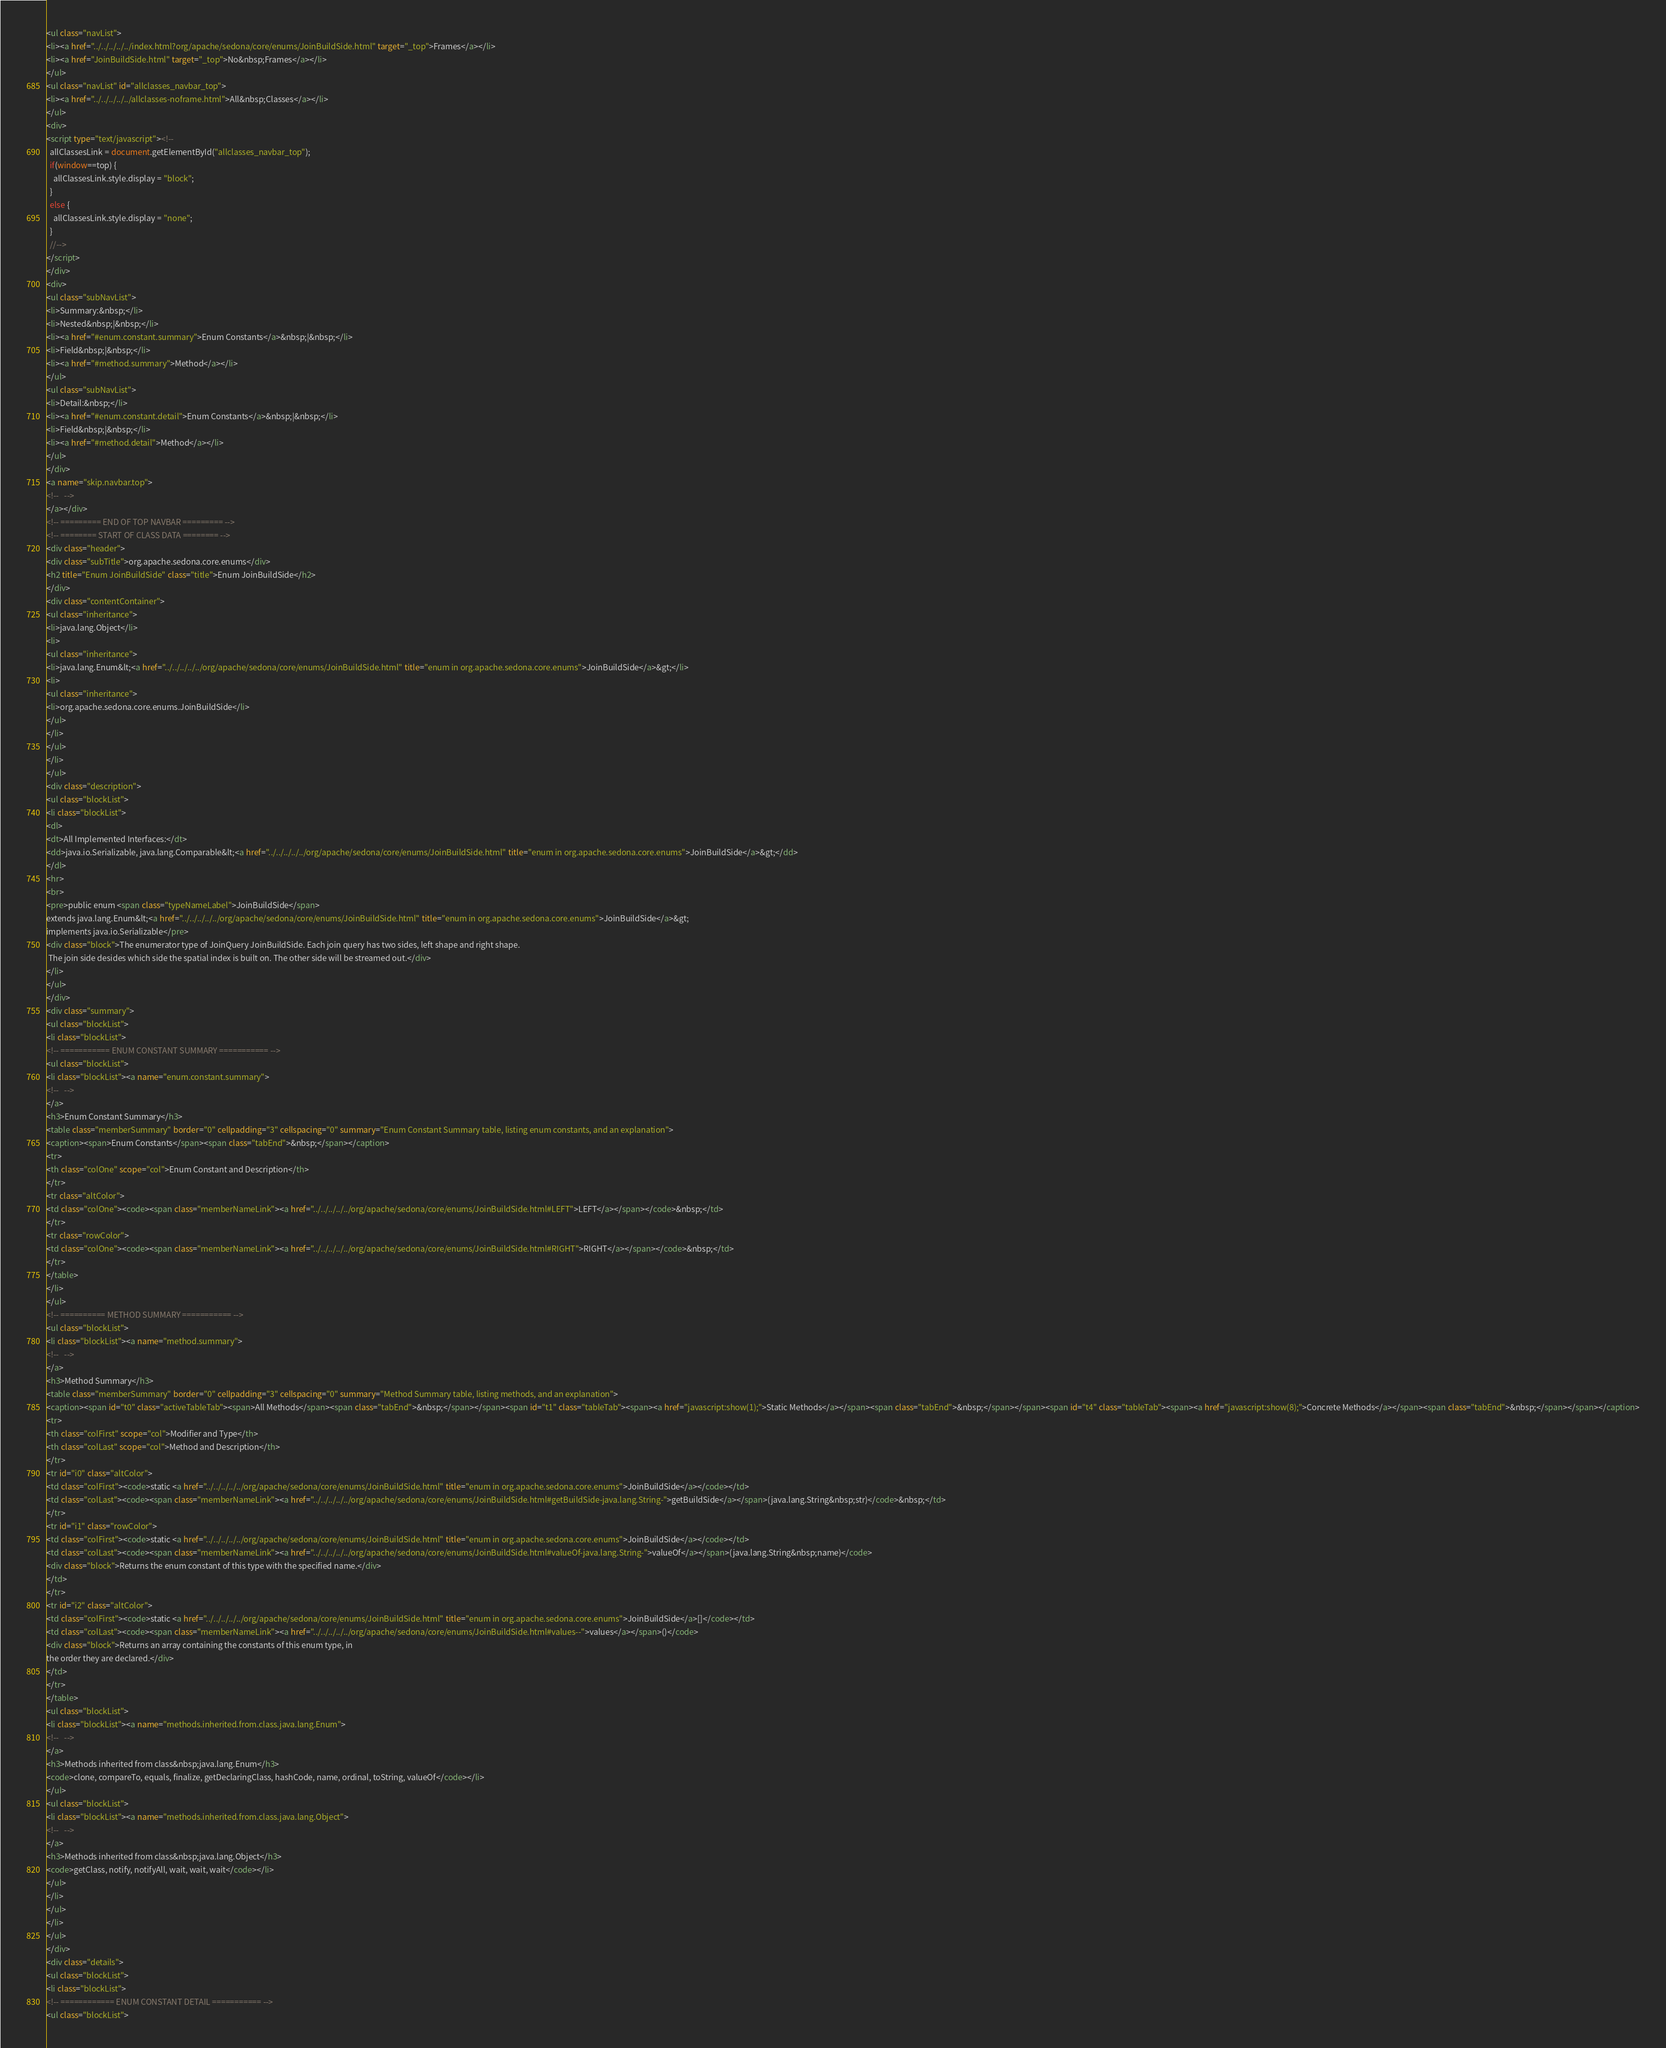Convert code to text. <code><loc_0><loc_0><loc_500><loc_500><_HTML_><ul class="navList">
<li><a href="../../../../../index.html?org/apache/sedona/core/enums/JoinBuildSide.html" target="_top">Frames</a></li>
<li><a href="JoinBuildSide.html" target="_top">No&nbsp;Frames</a></li>
</ul>
<ul class="navList" id="allclasses_navbar_top">
<li><a href="../../../../../allclasses-noframe.html">All&nbsp;Classes</a></li>
</ul>
<div>
<script type="text/javascript"><!--
  allClassesLink = document.getElementById("allclasses_navbar_top");
  if(window==top) {
    allClassesLink.style.display = "block";
  }
  else {
    allClassesLink.style.display = "none";
  }
  //-->
</script>
</div>
<div>
<ul class="subNavList">
<li>Summary:&nbsp;</li>
<li>Nested&nbsp;|&nbsp;</li>
<li><a href="#enum.constant.summary">Enum Constants</a>&nbsp;|&nbsp;</li>
<li>Field&nbsp;|&nbsp;</li>
<li><a href="#method.summary">Method</a></li>
</ul>
<ul class="subNavList">
<li>Detail:&nbsp;</li>
<li><a href="#enum.constant.detail">Enum Constants</a>&nbsp;|&nbsp;</li>
<li>Field&nbsp;|&nbsp;</li>
<li><a href="#method.detail">Method</a></li>
</ul>
</div>
<a name="skip.navbar.top">
<!--   -->
</a></div>
<!-- ========= END OF TOP NAVBAR ========= -->
<!-- ======== START OF CLASS DATA ======== -->
<div class="header">
<div class="subTitle">org.apache.sedona.core.enums</div>
<h2 title="Enum JoinBuildSide" class="title">Enum JoinBuildSide</h2>
</div>
<div class="contentContainer">
<ul class="inheritance">
<li>java.lang.Object</li>
<li>
<ul class="inheritance">
<li>java.lang.Enum&lt;<a href="../../../../../org/apache/sedona/core/enums/JoinBuildSide.html" title="enum in org.apache.sedona.core.enums">JoinBuildSide</a>&gt;</li>
<li>
<ul class="inheritance">
<li>org.apache.sedona.core.enums.JoinBuildSide</li>
</ul>
</li>
</ul>
</li>
</ul>
<div class="description">
<ul class="blockList">
<li class="blockList">
<dl>
<dt>All Implemented Interfaces:</dt>
<dd>java.io.Serializable, java.lang.Comparable&lt;<a href="../../../../../org/apache/sedona/core/enums/JoinBuildSide.html" title="enum in org.apache.sedona.core.enums">JoinBuildSide</a>&gt;</dd>
</dl>
<hr>
<br>
<pre>public enum <span class="typeNameLabel">JoinBuildSide</span>
extends java.lang.Enum&lt;<a href="../../../../../org/apache/sedona/core/enums/JoinBuildSide.html" title="enum in org.apache.sedona.core.enums">JoinBuildSide</a>&gt;
implements java.io.Serializable</pre>
<div class="block">The enumerator type of JoinQuery JoinBuildSide. Each join query has two sides, left shape and right shape.
 The join side desides which side the spatial index is built on. The other side will be streamed out.</div>
</li>
</ul>
</div>
<div class="summary">
<ul class="blockList">
<li class="blockList">
<!-- =========== ENUM CONSTANT SUMMARY =========== -->
<ul class="blockList">
<li class="blockList"><a name="enum.constant.summary">
<!--   -->
</a>
<h3>Enum Constant Summary</h3>
<table class="memberSummary" border="0" cellpadding="3" cellspacing="0" summary="Enum Constant Summary table, listing enum constants, and an explanation">
<caption><span>Enum Constants</span><span class="tabEnd">&nbsp;</span></caption>
<tr>
<th class="colOne" scope="col">Enum Constant and Description</th>
</tr>
<tr class="altColor">
<td class="colOne"><code><span class="memberNameLink"><a href="../../../../../org/apache/sedona/core/enums/JoinBuildSide.html#LEFT">LEFT</a></span></code>&nbsp;</td>
</tr>
<tr class="rowColor">
<td class="colOne"><code><span class="memberNameLink"><a href="../../../../../org/apache/sedona/core/enums/JoinBuildSide.html#RIGHT">RIGHT</a></span></code>&nbsp;</td>
</tr>
</table>
</li>
</ul>
<!-- ========== METHOD SUMMARY =========== -->
<ul class="blockList">
<li class="blockList"><a name="method.summary">
<!--   -->
</a>
<h3>Method Summary</h3>
<table class="memberSummary" border="0" cellpadding="3" cellspacing="0" summary="Method Summary table, listing methods, and an explanation">
<caption><span id="t0" class="activeTableTab"><span>All Methods</span><span class="tabEnd">&nbsp;</span></span><span id="t1" class="tableTab"><span><a href="javascript:show(1);">Static Methods</a></span><span class="tabEnd">&nbsp;</span></span><span id="t4" class="tableTab"><span><a href="javascript:show(8);">Concrete Methods</a></span><span class="tabEnd">&nbsp;</span></span></caption>
<tr>
<th class="colFirst" scope="col">Modifier and Type</th>
<th class="colLast" scope="col">Method and Description</th>
</tr>
<tr id="i0" class="altColor">
<td class="colFirst"><code>static <a href="../../../../../org/apache/sedona/core/enums/JoinBuildSide.html" title="enum in org.apache.sedona.core.enums">JoinBuildSide</a></code></td>
<td class="colLast"><code><span class="memberNameLink"><a href="../../../../../org/apache/sedona/core/enums/JoinBuildSide.html#getBuildSide-java.lang.String-">getBuildSide</a></span>(java.lang.String&nbsp;str)</code>&nbsp;</td>
</tr>
<tr id="i1" class="rowColor">
<td class="colFirst"><code>static <a href="../../../../../org/apache/sedona/core/enums/JoinBuildSide.html" title="enum in org.apache.sedona.core.enums">JoinBuildSide</a></code></td>
<td class="colLast"><code><span class="memberNameLink"><a href="../../../../../org/apache/sedona/core/enums/JoinBuildSide.html#valueOf-java.lang.String-">valueOf</a></span>(java.lang.String&nbsp;name)</code>
<div class="block">Returns the enum constant of this type with the specified name.</div>
</td>
</tr>
<tr id="i2" class="altColor">
<td class="colFirst"><code>static <a href="../../../../../org/apache/sedona/core/enums/JoinBuildSide.html" title="enum in org.apache.sedona.core.enums">JoinBuildSide</a>[]</code></td>
<td class="colLast"><code><span class="memberNameLink"><a href="../../../../../org/apache/sedona/core/enums/JoinBuildSide.html#values--">values</a></span>()</code>
<div class="block">Returns an array containing the constants of this enum type, in
the order they are declared.</div>
</td>
</tr>
</table>
<ul class="blockList">
<li class="blockList"><a name="methods.inherited.from.class.java.lang.Enum">
<!--   -->
</a>
<h3>Methods inherited from class&nbsp;java.lang.Enum</h3>
<code>clone, compareTo, equals, finalize, getDeclaringClass, hashCode, name, ordinal, toString, valueOf</code></li>
</ul>
<ul class="blockList">
<li class="blockList"><a name="methods.inherited.from.class.java.lang.Object">
<!--   -->
</a>
<h3>Methods inherited from class&nbsp;java.lang.Object</h3>
<code>getClass, notify, notifyAll, wait, wait, wait</code></li>
</ul>
</li>
</ul>
</li>
</ul>
</div>
<div class="details">
<ul class="blockList">
<li class="blockList">
<!-- ============ ENUM CONSTANT DETAIL =========== -->
<ul class="blockList"></code> 